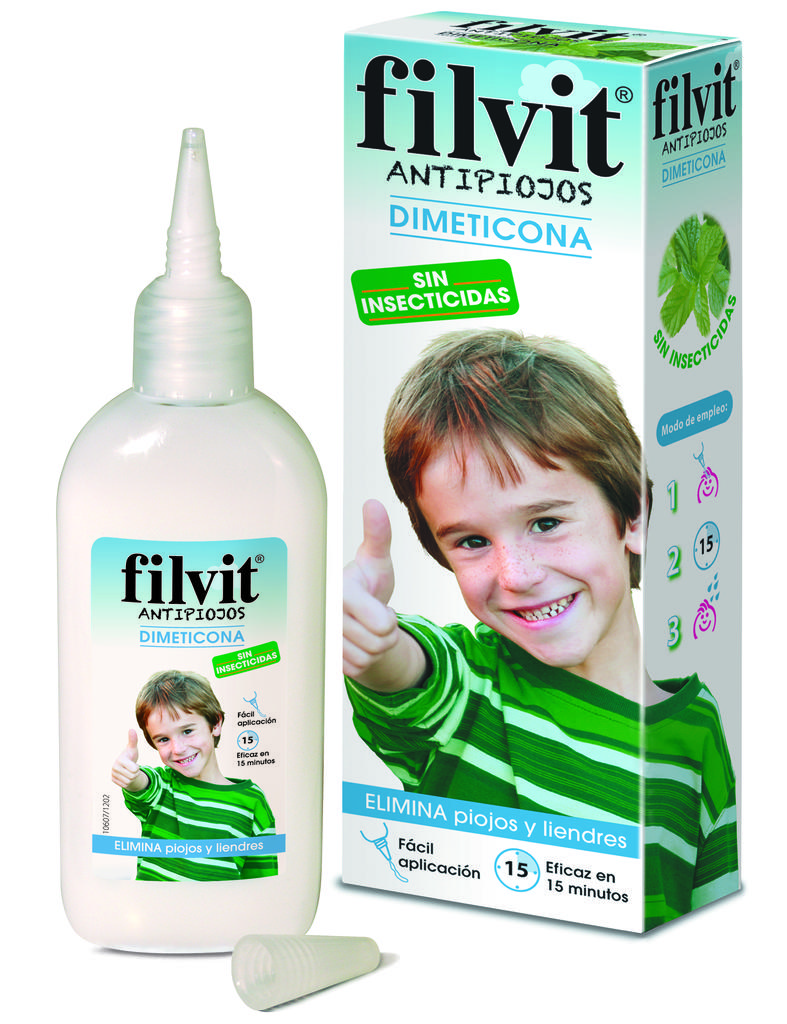What is wrote in green above the kid?
Provide a short and direct response. Sin insecticidas. 